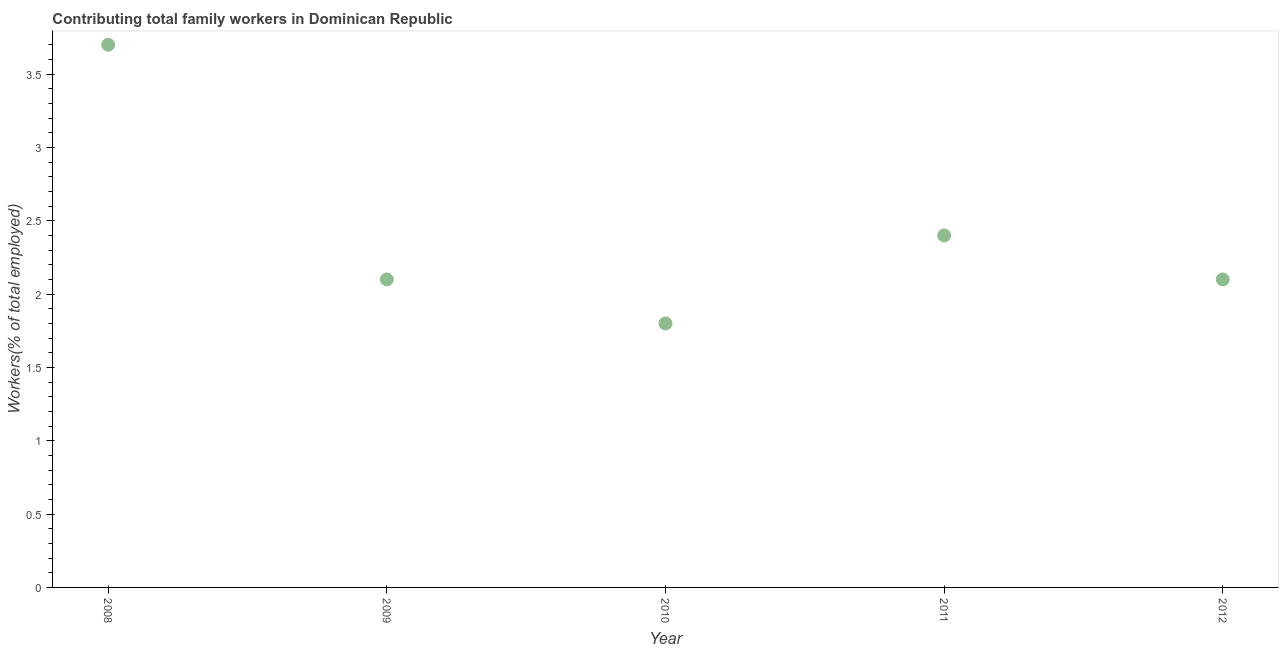What is the contributing family workers in 2009?
Ensure brevity in your answer.  2.1. Across all years, what is the maximum contributing family workers?
Your response must be concise. 3.7. Across all years, what is the minimum contributing family workers?
Provide a short and direct response. 1.8. What is the sum of the contributing family workers?
Keep it short and to the point. 12.1. What is the difference between the contributing family workers in 2009 and 2011?
Offer a very short reply. -0.3. What is the average contributing family workers per year?
Your answer should be very brief. 2.42. What is the median contributing family workers?
Ensure brevity in your answer.  2.1. What is the ratio of the contributing family workers in 2008 to that in 2009?
Your response must be concise. 1.76. What is the difference between the highest and the second highest contributing family workers?
Your response must be concise. 1.3. What is the difference between the highest and the lowest contributing family workers?
Your answer should be compact. 1.9. Does the contributing family workers monotonically increase over the years?
Your answer should be compact. No. How many dotlines are there?
Provide a succinct answer. 1. How many years are there in the graph?
Provide a succinct answer. 5. Does the graph contain grids?
Offer a terse response. No. What is the title of the graph?
Keep it short and to the point. Contributing total family workers in Dominican Republic. What is the label or title of the Y-axis?
Your answer should be compact. Workers(% of total employed). What is the Workers(% of total employed) in 2008?
Keep it short and to the point. 3.7. What is the Workers(% of total employed) in 2009?
Your response must be concise. 2.1. What is the Workers(% of total employed) in 2010?
Offer a terse response. 1.8. What is the Workers(% of total employed) in 2011?
Provide a short and direct response. 2.4. What is the Workers(% of total employed) in 2012?
Provide a succinct answer. 2.1. What is the difference between the Workers(% of total employed) in 2008 and 2011?
Ensure brevity in your answer.  1.3. What is the difference between the Workers(% of total employed) in 2009 and 2011?
Offer a terse response. -0.3. What is the difference between the Workers(% of total employed) in 2010 and 2011?
Give a very brief answer. -0.6. What is the ratio of the Workers(% of total employed) in 2008 to that in 2009?
Keep it short and to the point. 1.76. What is the ratio of the Workers(% of total employed) in 2008 to that in 2010?
Your answer should be compact. 2.06. What is the ratio of the Workers(% of total employed) in 2008 to that in 2011?
Make the answer very short. 1.54. What is the ratio of the Workers(% of total employed) in 2008 to that in 2012?
Give a very brief answer. 1.76. What is the ratio of the Workers(% of total employed) in 2009 to that in 2010?
Make the answer very short. 1.17. What is the ratio of the Workers(% of total employed) in 2009 to that in 2012?
Offer a terse response. 1. What is the ratio of the Workers(% of total employed) in 2010 to that in 2011?
Provide a short and direct response. 0.75. What is the ratio of the Workers(% of total employed) in 2010 to that in 2012?
Your answer should be very brief. 0.86. What is the ratio of the Workers(% of total employed) in 2011 to that in 2012?
Ensure brevity in your answer.  1.14. 